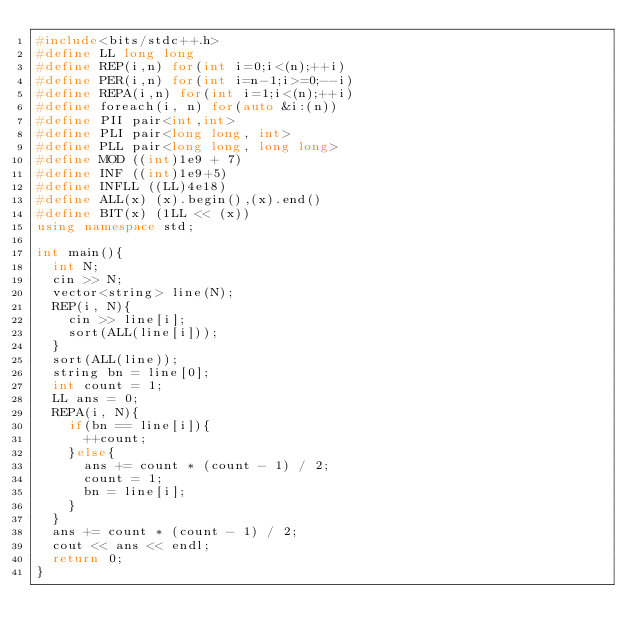<code> <loc_0><loc_0><loc_500><loc_500><_C++_>#include<bits/stdc++.h>
#define LL long long
#define REP(i,n) for(int i=0;i<(n);++i)
#define PER(i,n) for(int i=n-1;i>=0;--i)
#define REPA(i,n) for(int i=1;i<(n);++i)
#define foreach(i, n) for(auto &i:(n))
#define PII pair<int,int>
#define PLI pair<long long, int>
#define PLL pair<long long, long long>
#define MOD ((int)1e9 + 7)
#define INF ((int)1e9+5)
#define INFLL ((LL)4e18)
#define ALL(x) (x).begin(),(x).end()
#define BIT(x) (1LL << (x))
using namespace std;

int main(){
	int N;
	cin >> N;
	vector<string> line(N);
	REP(i, N){
		cin >> line[i];
		sort(ALL(line[i]));
	}
	sort(ALL(line));
	string bn = line[0];
	int count = 1;
	LL ans = 0;
	REPA(i, N){
		if(bn == line[i]){
			++count;
		}else{
			ans += count * (count - 1) / 2;
			count = 1;
			bn = line[i];
		}
	}
	ans += count * (count - 1) / 2;
	cout << ans << endl;
	return 0;
}
</code> 